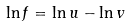Convert formula to latex. <formula><loc_0><loc_0><loc_500><loc_500>\ln f = \ln u - \ln v</formula> 